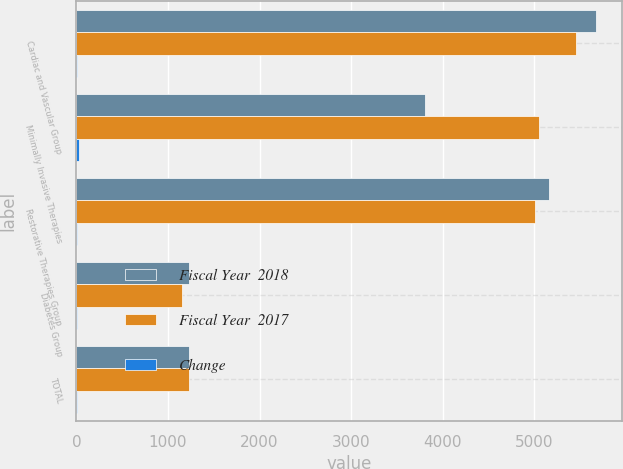Convert chart. <chart><loc_0><loc_0><loc_500><loc_500><stacked_bar_chart><ecel><fcel>Cardiac and Vascular Group<fcel>Minimally Invasive Therapies<fcel>Restorative Therapies Group<fcel>Diabetes Group<fcel>TOTAL<nl><fcel>Fiscal Year  2018<fcel>5681<fcel>3804<fcel>5164<fcel>1226<fcel>1226<nl><fcel>Fiscal Year  2017<fcel>5454<fcel>5049<fcel>5012<fcel>1148<fcel>1226<nl><fcel>Change<fcel>4<fcel>25<fcel>3<fcel>7<fcel>5<nl></chart> 